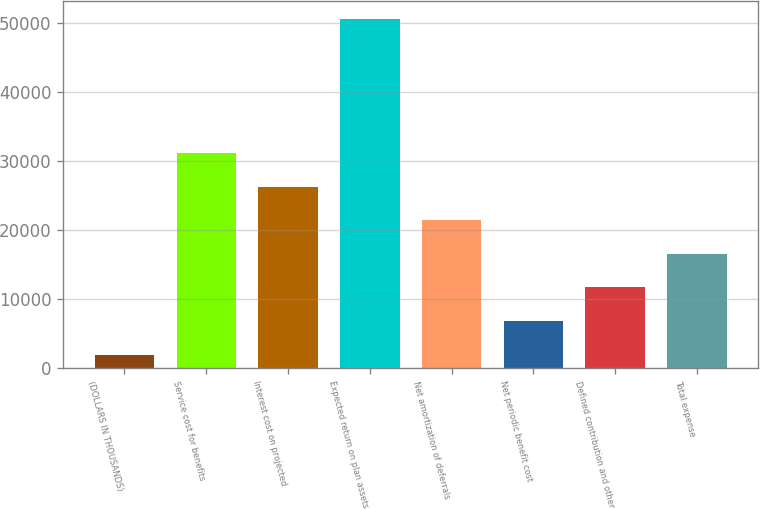Convert chart. <chart><loc_0><loc_0><loc_500><loc_500><bar_chart><fcel>(DOLLARS IN THOUSANDS)<fcel>Service cost for benefits<fcel>Interest cost on projected<fcel>Expected return on plan assets<fcel>Net amortization of deferrals<fcel>Net periodic benefit cost<fcel>Defined contribution and other<fcel>Total expense<nl><fcel>2017<fcel>31182.4<fcel>26321.5<fcel>50626<fcel>21460.6<fcel>6877.9<fcel>11738.8<fcel>16599.7<nl></chart> 